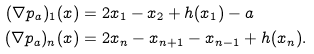Convert formula to latex. <formula><loc_0><loc_0><loc_500><loc_500>( \nabla \L p _ { a } ) _ { 1 } ( x ) & = 2 x _ { 1 } - x _ { 2 } + h ( x _ { 1 } ) - a \\ ( \nabla \L p _ { a } ) _ { n } ( x ) & = 2 x _ { n } - x _ { n + 1 } - x _ { n - 1 } + h ( x _ { n } ) .</formula> 